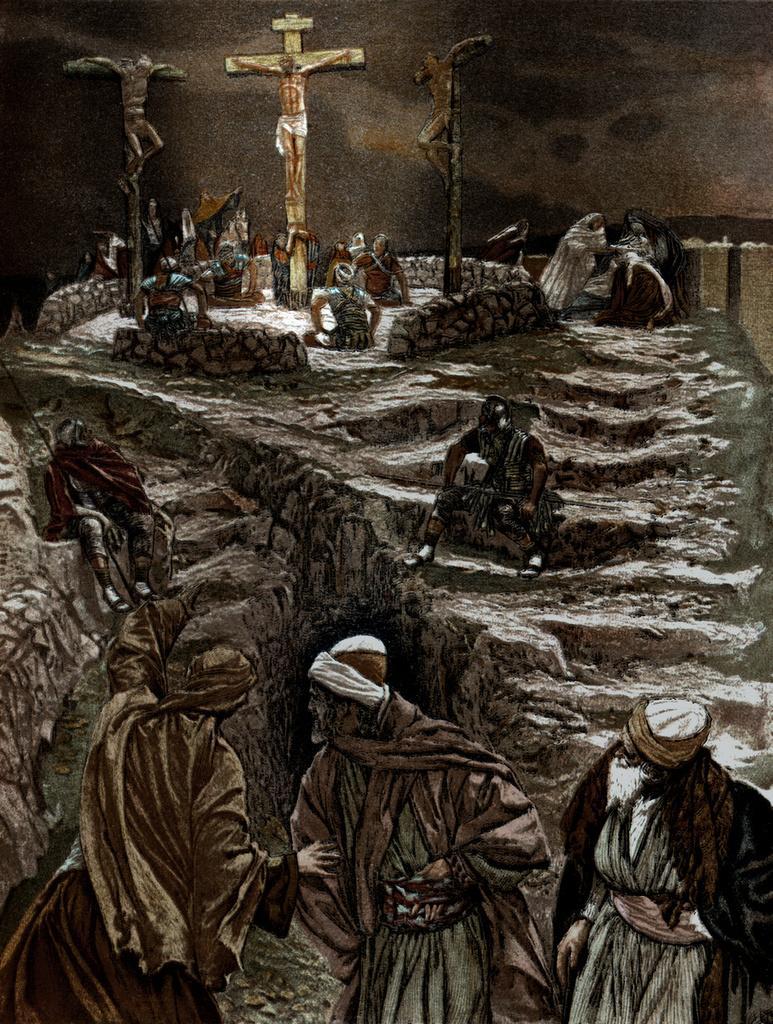Describe this image in one or two sentences. In this image I can see three persons standing, at back I can see few stairs and few people sitting on the stairs. I can also see symbol of god at the back. 